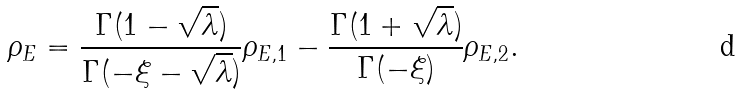Convert formula to latex. <formula><loc_0><loc_0><loc_500><loc_500>\rho _ { E } = \frac { \Gamma ( 1 - \sqrt { \lambda } ) } { \Gamma ( - \xi - \sqrt { \lambda } ) } \rho _ { E , 1 } - \frac { \Gamma ( 1 + \sqrt { \lambda } ) } { \Gamma ( - \xi ) } \rho _ { E , 2 } .</formula> 